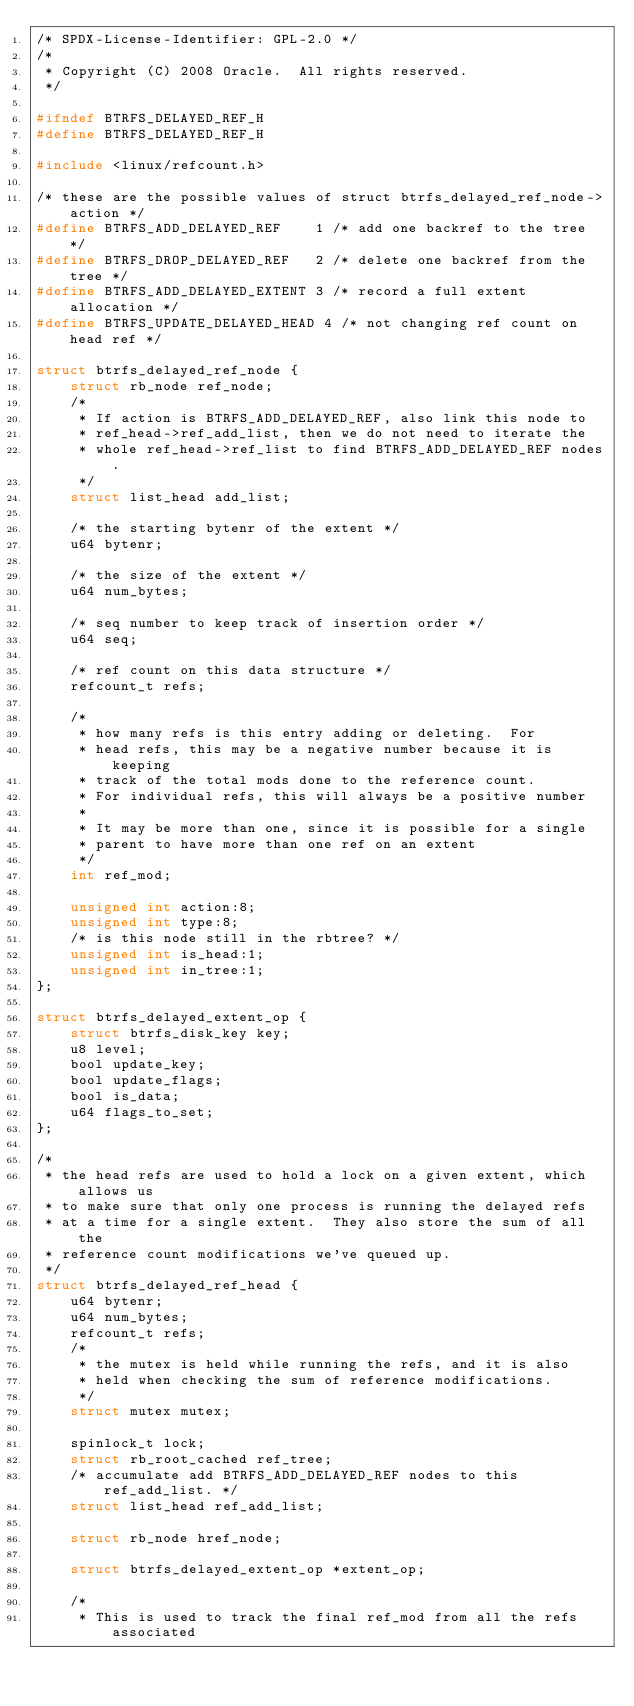<code> <loc_0><loc_0><loc_500><loc_500><_C_>/* SPDX-License-Identifier: GPL-2.0 */
/*
 * Copyright (C) 2008 Oracle.  All rights reserved.
 */

#ifndef BTRFS_DELAYED_REF_H
#define BTRFS_DELAYED_REF_H

#include <linux/refcount.h>

/* these are the possible values of struct btrfs_delayed_ref_node->action */
#define BTRFS_ADD_DELAYED_REF    1 /* add one backref to the tree */
#define BTRFS_DROP_DELAYED_REF   2 /* delete one backref from the tree */
#define BTRFS_ADD_DELAYED_EXTENT 3 /* record a full extent allocation */
#define BTRFS_UPDATE_DELAYED_HEAD 4 /* not changing ref count on head ref */

struct btrfs_delayed_ref_node {
	struct rb_node ref_node;
	/*
	 * If action is BTRFS_ADD_DELAYED_REF, also link this node to
	 * ref_head->ref_add_list, then we do not need to iterate the
	 * whole ref_head->ref_list to find BTRFS_ADD_DELAYED_REF nodes.
	 */
	struct list_head add_list;

	/* the starting bytenr of the extent */
	u64 bytenr;

	/* the size of the extent */
	u64 num_bytes;

	/* seq number to keep track of insertion order */
	u64 seq;

	/* ref count on this data structure */
	refcount_t refs;

	/*
	 * how many refs is this entry adding or deleting.  For
	 * head refs, this may be a negative number because it is keeping
	 * track of the total mods done to the reference count.
	 * For individual refs, this will always be a positive number
	 *
	 * It may be more than one, since it is possible for a single
	 * parent to have more than one ref on an extent
	 */
	int ref_mod;

	unsigned int action:8;
	unsigned int type:8;
	/* is this node still in the rbtree? */
	unsigned int is_head:1;
	unsigned int in_tree:1;
};

struct btrfs_delayed_extent_op {
	struct btrfs_disk_key key;
	u8 level;
	bool update_key;
	bool update_flags;
	bool is_data;
	u64 flags_to_set;
};

/*
 * the head refs are used to hold a lock on a given extent, which allows us
 * to make sure that only one process is running the delayed refs
 * at a time for a single extent.  They also store the sum of all the
 * reference count modifications we've queued up.
 */
struct btrfs_delayed_ref_head {
	u64 bytenr;
	u64 num_bytes;
	refcount_t refs;
	/*
	 * the mutex is held while running the refs, and it is also
	 * held when checking the sum of reference modifications.
	 */
	struct mutex mutex;

	spinlock_t lock;
	struct rb_root_cached ref_tree;
	/* accumulate add BTRFS_ADD_DELAYED_REF nodes to this ref_add_list. */
	struct list_head ref_add_list;

	struct rb_node href_node;

	struct btrfs_delayed_extent_op *extent_op;

	/*
	 * This is used to track the final ref_mod from all the refs associated</code> 